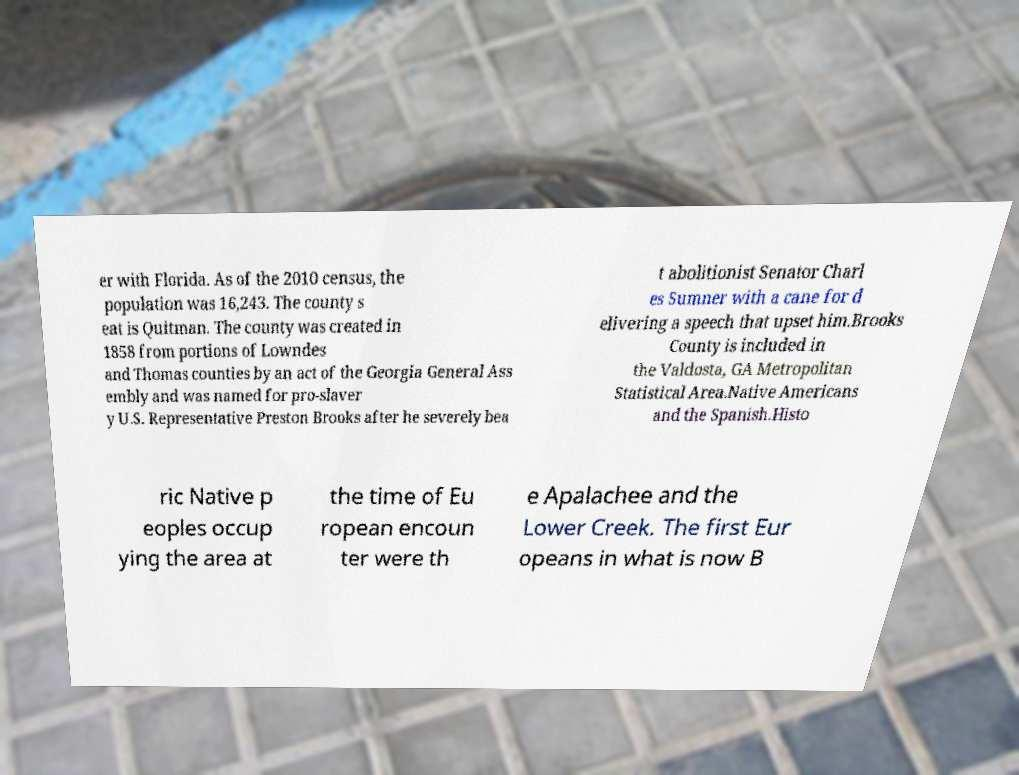Please read and relay the text visible in this image. What does it say? er with Florida. As of the 2010 census, the population was 16,243. The county s eat is Quitman. The county was created in 1858 from portions of Lowndes and Thomas counties by an act of the Georgia General Ass embly and was named for pro-slaver y U.S. Representative Preston Brooks after he severely bea t abolitionist Senator Charl es Sumner with a cane for d elivering a speech that upset him.Brooks County is included in the Valdosta, GA Metropolitan Statistical Area.Native Americans and the Spanish.Histo ric Native p eoples occup ying the area at the time of Eu ropean encoun ter were th e Apalachee and the Lower Creek. The first Eur opeans in what is now B 